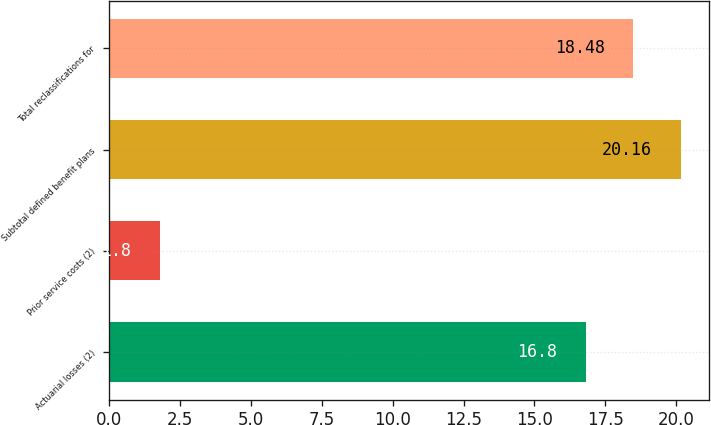Convert chart to OTSL. <chart><loc_0><loc_0><loc_500><loc_500><bar_chart><fcel>Actuarial losses (2)<fcel>Prior service costs (2)<fcel>Subtotal defined benefit plans<fcel>Total reclassifications for<nl><fcel>16.8<fcel>1.8<fcel>20.16<fcel>18.48<nl></chart> 